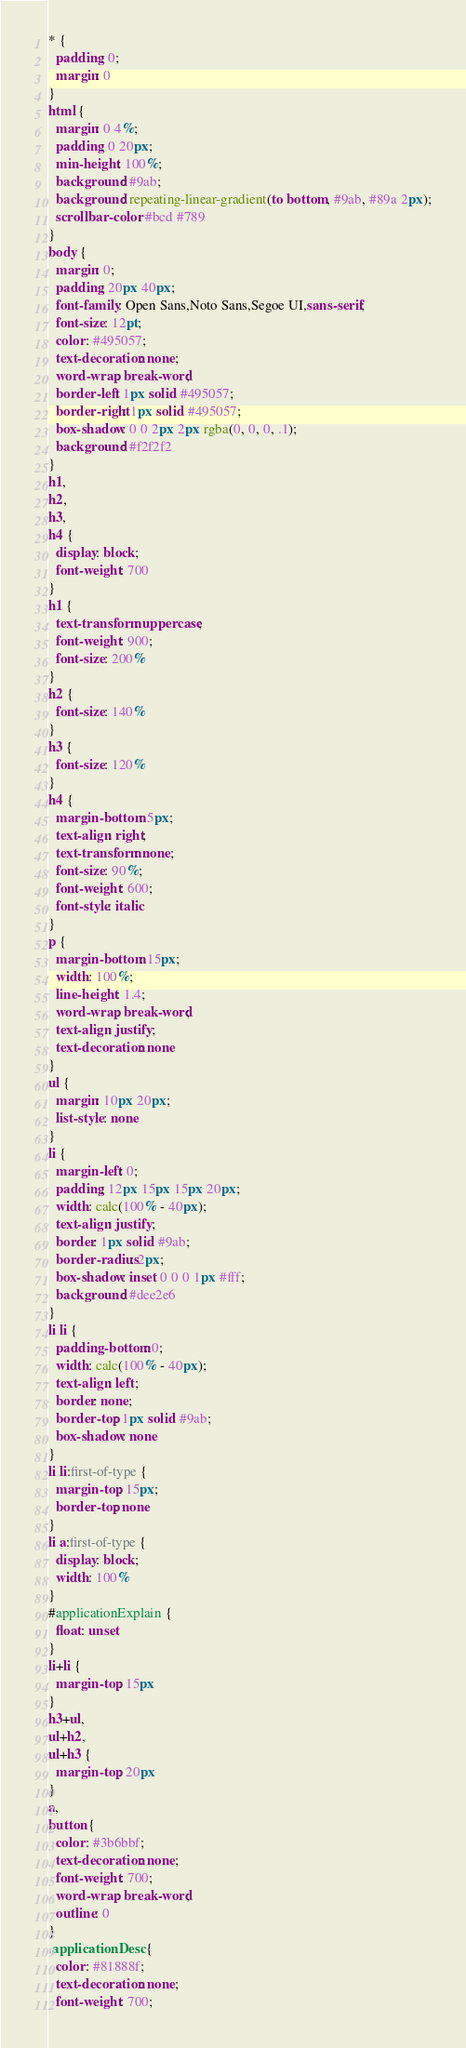Convert code to text. <code><loc_0><loc_0><loc_500><loc_500><_CSS_>* {
  padding: 0;
  margin: 0
}
html {
  margin: 0 4%;
  padding: 0 20px;
  min-height: 100%;
  background: #9ab;
  background: repeating-linear-gradient(to bottom, #9ab, #89a 2px);
  scrollbar-color: #bcd #789
}
body {
  margin: 0;
  padding: 20px 40px;
  font-family: Open Sans,Noto Sans,Segoe UI,sans-serif;
  font-size: 12pt;
  color: #495057;
  text-decoration: none;
  word-wrap: break-word;
  border-left: 1px solid #495057;
  border-right: 1px solid #495057;
  box-shadow: 0 0 2px 2px rgba(0, 0, 0, .1);
  background: #f2f2f2
}
h1,
h2,
h3,
h4 {
  display: block;
  font-weight: 700
}
h1 {
  text-transform: uppercase;
  font-weight: 900;
  font-size: 200%
}
h2 {
  font-size: 140%
}
h3 {
  font-size: 120%
}
h4 {
  margin-bottom: 5px;
  text-align: right;
  text-transform: none;
  font-size: 90%;
  font-weight: 600;
  font-style: italic
}
p {
  margin-bottom: 15px;
  width: 100%;
  line-height: 1.4;
  word-wrap: break-word;
  text-align: justify;
  text-decoration: none
}
ul {
  margin: 10px 20px;
  list-style: none
}
li {
  margin-left: 0;
  padding: 12px 15px 15px 20px;
  width: calc(100% - 40px);
  text-align: justify;
  border: 1px solid #9ab;
  border-radius: 2px;
  box-shadow: inset 0 0 0 1px #fff;
  background: #dee2e6
}
li li {
  padding-bottom: 0;
  width: calc(100% - 40px);
  text-align: left;
  border: none;
  border-top: 1px solid #9ab;
  box-shadow: none
}
li li:first-of-type {
  margin-top: 15px;
  border-top: none
}
li a:first-of-type {
  display: block;
  width: 100%
}
#applicationExplain {
  float: unset
}
li+li {
  margin-top: 15px
}
h3+ul,
ul+h2,
ul+h3 {
  margin-top: 20px
}
a,
button {
  color: #3b6bbf;
  text-decoration: none;
  font-weight: 700;
  word-wrap: break-word;
  outline: 0
}
.applicationDesc {
  color: #81888f;
  text-decoration: none;
  font-weight: 700;</code> 